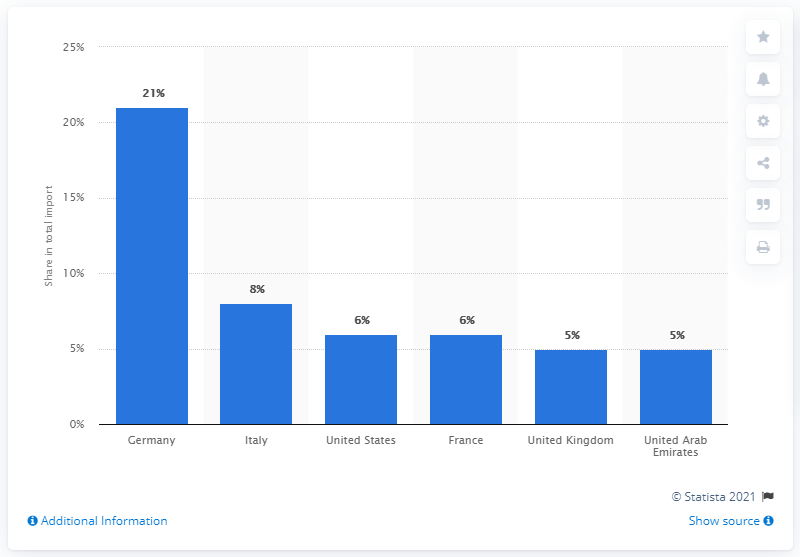Specify some key components in this picture. According to data from 2019, Germany was the largest import partner of Switzerland. 